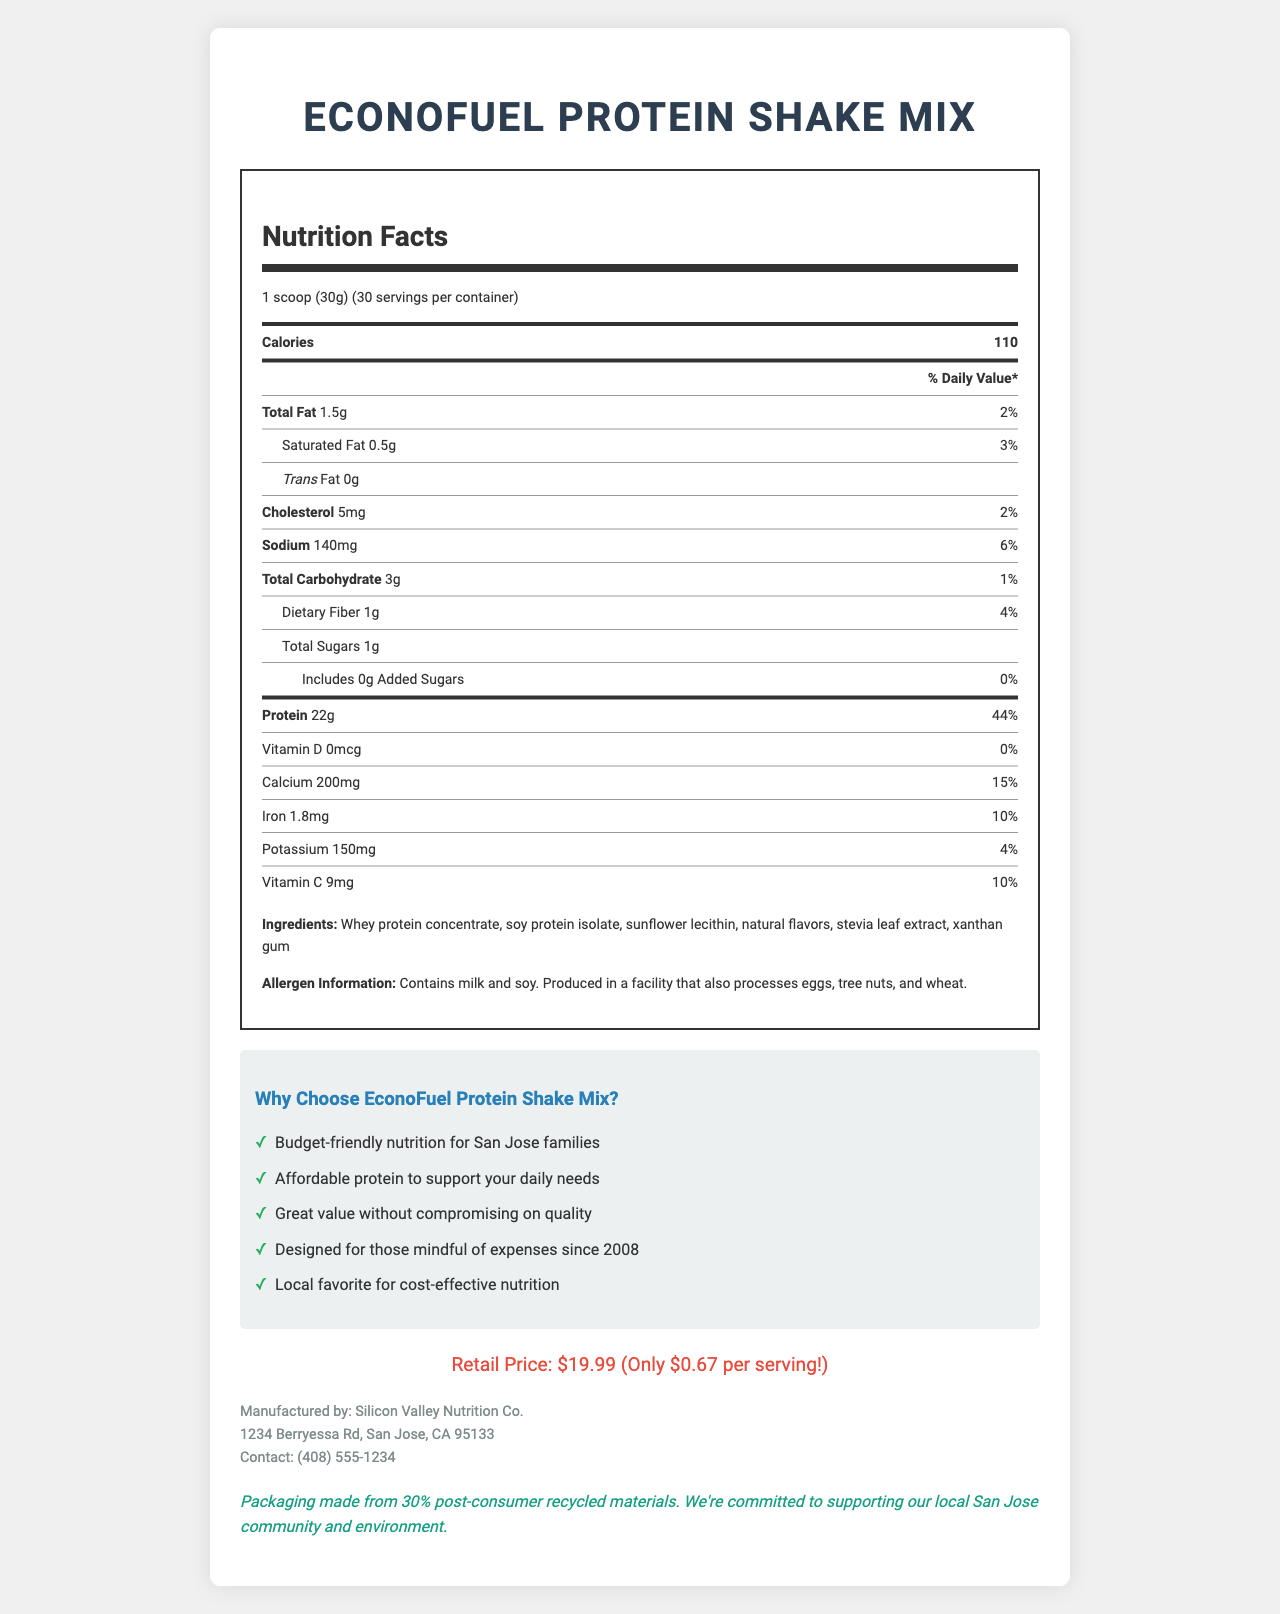what is the serving size of EconoFuel Protein Shake Mix? The serving size is explicitly stated in the document as "1 scoop (30g)".
Answer: 1 scoop (30g) how many servings are there per container? The document mentions that there are 30 servings per container.
Answer: 30 what is the main ingredient in EconoFuel Protein Shake Mix? The first ingredient listed is Whey protein concentrate, which usually indicates it is the main ingredient.
Answer: Whey protein concentrate how much protein is there per serving? According to the Nutrition Facts, there are 22g of protein per serving.
Answer: 22g what are the dietary fiber and total sugar amounts per serving? From the nutrition label, dietary fiber is listed as 1g and total sugars as 1g per serving.
Answer: Dietary Fiber: 1g, Total Sugars: 1g how much does each serving cost? (a) $0.50, (b) $0.67, (c) $1.00, (d) $1.50 The price info states that the retail price is $19.99 for 30 servings, making the cost per serving $0.67.
Answer: (b) $0.67 which vitamin is absent in the EconoFuel Protein Shake Mix? (i) Vitamin A, (ii) Vitamin C, (iii) Vitamin D, (iv) Vitamin E The nutrition label indicates there is 0mcg of Vitamin D, while other vitamins are present.
Answer: (iii) Vitamin D is EconoFuel Protein Shake Mix gluten-free? The document doesn't provide information on whether the protein shake mix is gluten-free.
Answer: Cannot be determined does this product contain any allergens? The allergen information states that the product contains milk and soy and is produced in a facility that processes eggs, tree nuts, and wheat.
Answer: Yes summarize the nutritional benefits and affordability aspects of EconoFuel Protein Shake Mix. The document highlights that EconoFuel Protein Shake Mix is rich in protein, low in calories, fats, and sugars, and affordable at $0.67 per serving. It also emphasizes local production and environmentally friendly packaging.
Answer: EconoFuel Protein Shake Mix offers high protein content (22g per serving) with minimal fats and sugars, making it a great option for those looking for budget-friendly nutrition. With a retail price of $19.99, each serving costs only $0.67, providing an affordable yet nutritious option for individuals concerned with cost since the 2008 financial crisis. Additionally, the product is produced by Silicon Valley Nutrition Co. in San Jose, CA, supporting the local community with sustainable packaging. what is the retail price of EconoFuel Protein Shake Mix? The price info section clearly lists the retail price as $19.99.
Answer: $19.99 what company manufactures EconoFuel Protein Shake Mix? Manufacturer information indicates that this product is made by Silicon Valley Nutrition Co.
Answer: Silicon Valley Nutrition Co. how much calcium is in one serving? The nutrition facts label shows that each serving contains 200mg of calcium.
Answer: 200mg which nutrient has the highest daily value percentage per serving? (i) Protein, (ii) Calcium, (iii) Iron, (iv) Sodium The daily value percentage for protein is 44%, which is higher than the other listed nutrients, making it the highest.
Answer: (i) Protein 